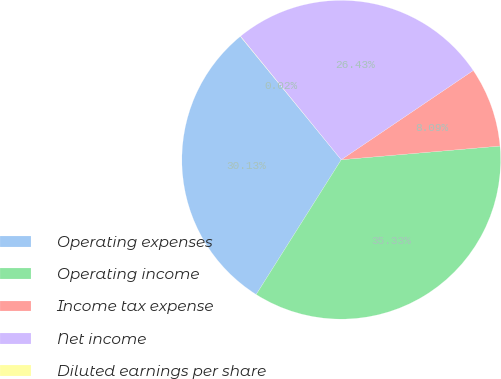<chart> <loc_0><loc_0><loc_500><loc_500><pie_chart><fcel>Operating expenses<fcel>Operating income<fcel>Income tax expense<fcel>Net income<fcel>Diluted earnings per share<nl><fcel>30.13%<fcel>35.33%<fcel>8.09%<fcel>26.43%<fcel>0.02%<nl></chart> 